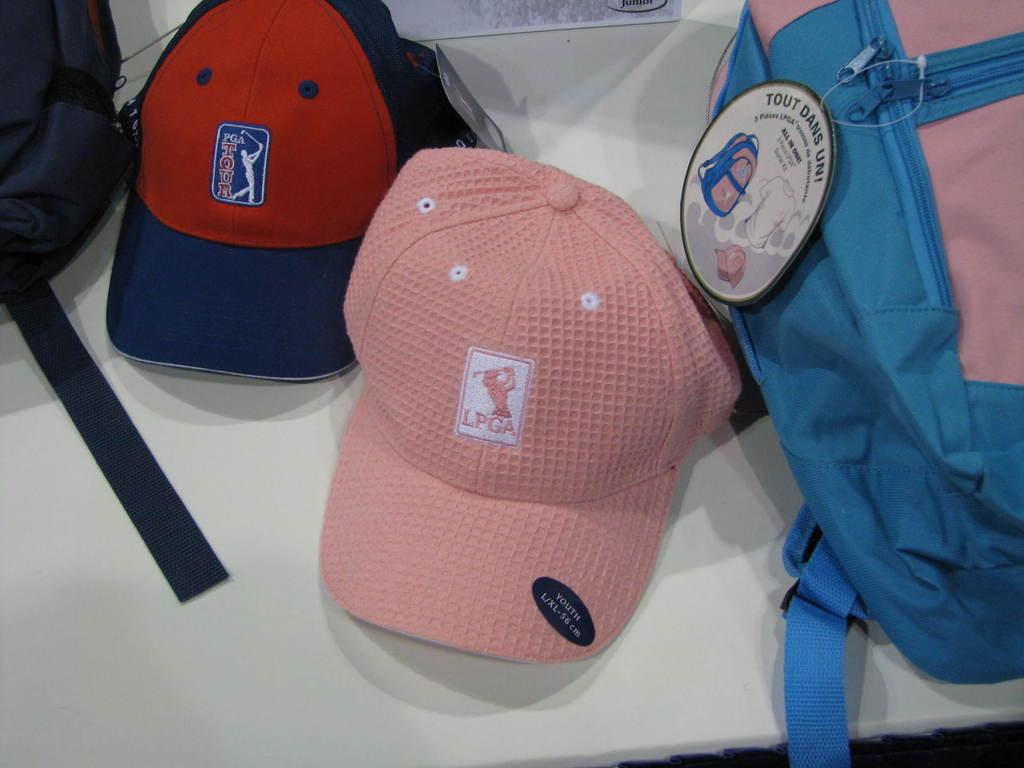<image>
Write a terse but informative summary of the picture. Backpack next to a pink cap that says LPGA. 